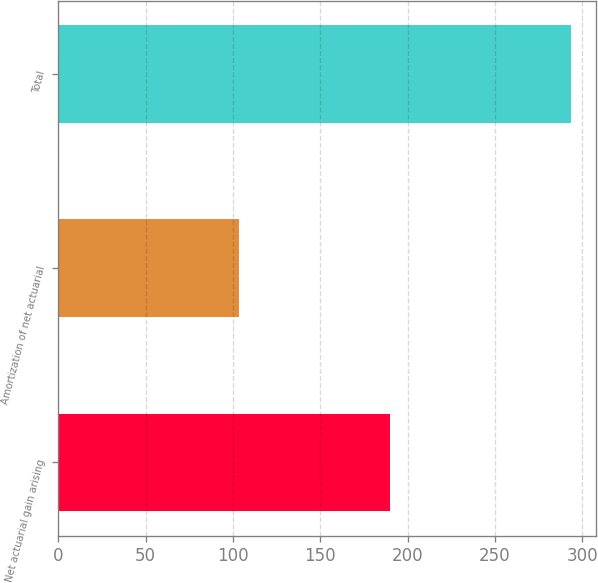Convert chart to OTSL. <chart><loc_0><loc_0><loc_500><loc_500><bar_chart><fcel>Net actuarial gain arising<fcel>Amortization of net actuarial<fcel>Total<nl><fcel>189.8<fcel>103.3<fcel>293.5<nl></chart> 